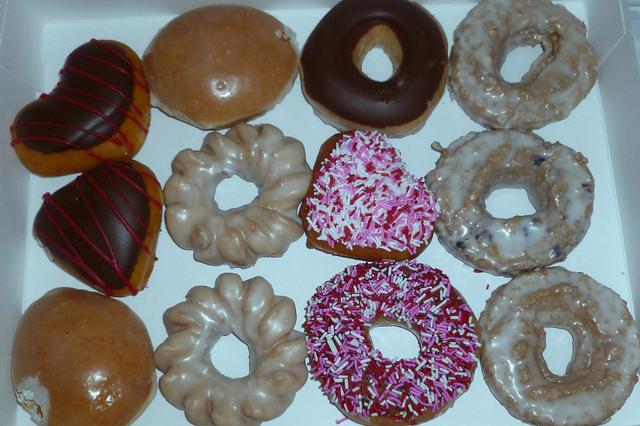How many doughnuts are there?
Answer briefly. 12. Do the all donuts have fillings inside?
Write a very short answer. No. Are the donuts the same kind?
Answer briefly. No. 